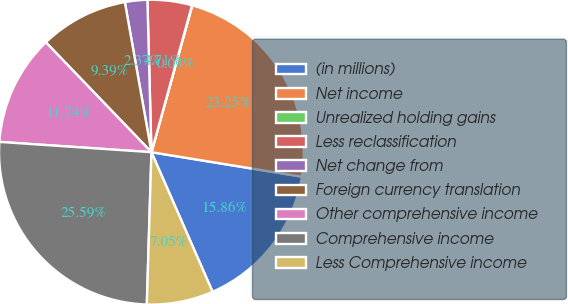Convert chart. <chart><loc_0><loc_0><loc_500><loc_500><pie_chart><fcel>(in millions)<fcel>Net income<fcel>Unrealized holding gains<fcel>Less reclassification<fcel>Net change from<fcel>Foreign currency translation<fcel>Other comprehensive income<fcel>Comprehensive income<fcel>Less Comprehensive income<nl><fcel>15.86%<fcel>23.25%<fcel>0.03%<fcel>4.71%<fcel>2.37%<fcel>9.39%<fcel>11.74%<fcel>25.59%<fcel>7.05%<nl></chart> 